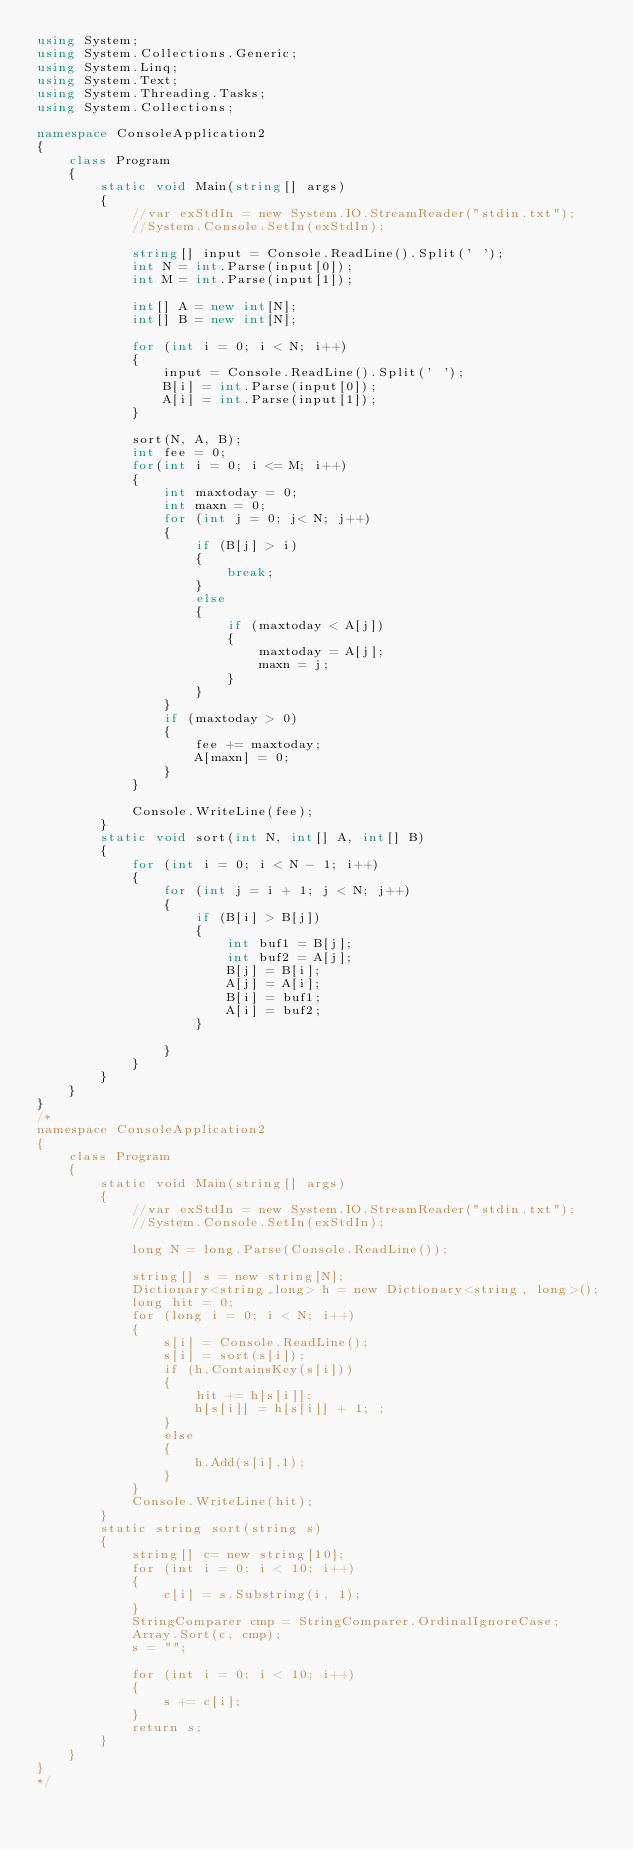<code> <loc_0><loc_0><loc_500><loc_500><_C#_>using System;
using System.Collections.Generic;
using System.Linq;
using System.Text;
using System.Threading.Tasks;
using System.Collections;

namespace ConsoleApplication2
{
    class Program
    {
        static void Main(string[] args)
        {
            //var exStdIn = new System.IO.StreamReader("stdin.txt");
            //System.Console.SetIn(exStdIn);

            string[] input = Console.ReadLine().Split(' ');
            int N = int.Parse(input[0]);
            int M = int.Parse(input[1]);

            int[] A = new int[N];
            int[] B = new int[N];

            for (int i = 0; i < N; i++)
            {
                input = Console.ReadLine().Split(' ');
                B[i] = int.Parse(input[0]);
                A[i] = int.Parse(input[1]);
            }

            sort(N, A, B);
            int fee = 0;
            for(int i = 0; i <= M; i++)
            {
                int maxtoday = 0;
                int maxn = 0;
                for (int j = 0; j< N; j++)
                {
                    if (B[j] > i)
                    {
                        break;
                    }
                    else
                    {
                        if (maxtoday < A[j])
                        {
                            maxtoday = A[j];
                            maxn = j;
                        }
                    }
                }
                if (maxtoday > 0)
                {
                    fee += maxtoday;
                    A[maxn] = 0;
                }
            }

            Console.WriteLine(fee);
        }
        static void sort(int N, int[] A, int[] B)
        {
            for (int i = 0; i < N - 1; i++)
            {
                for (int j = i + 1; j < N; j++)
                {
                    if (B[i] > B[j])
                    {
                        int buf1 = B[j];
                        int buf2 = A[j];
                        B[j] = B[i];
                        A[j] = A[i];
                        B[i] = buf1;
                        A[i] = buf2;
                    }

                }
            }
        }
    }
}
/*
namespace ConsoleApplication2
{
    class Program
    {
        static void Main(string[] args)
        {
            //var exStdIn = new System.IO.StreamReader("stdin.txt");
            //System.Console.SetIn(exStdIn);

            long N = long.Parse(Console.ReadLine());

            string[] s = new string[N];
            Dictionary<string,long> h = new Dictionary<string, long>();
            long hit = 0;
            for (long i = 0; i < N; i++)
            {
                s[i] = Console.ReadLine();
                s[i] = sort(s[i]);
                if (h.ContainsKey(s[i]))
                {
                    hit += h[s[i]];
                    h[s[i]] = h[s[i]] + 1; ;
                }
                else
                {
                    h.Add(s[i],1);
                }
            }
            Console.WriteLine(hit);
        }
        static string sort(string s)
        {
            string[] c= new string[10];
            for (int i = 0; i < 10; i++)
            {
                c[i] = s.Substring(i, 1);
            }
            StringComparer cmp = StringComparer.OrdinalIgnoreCase;
            Array.Sort(c, cmp);
            s = "";

            for (int i = 0; i < 10; i++)
            {
                s += c[i];
            }
            return s;
        }
    }
}
*/
</code> 